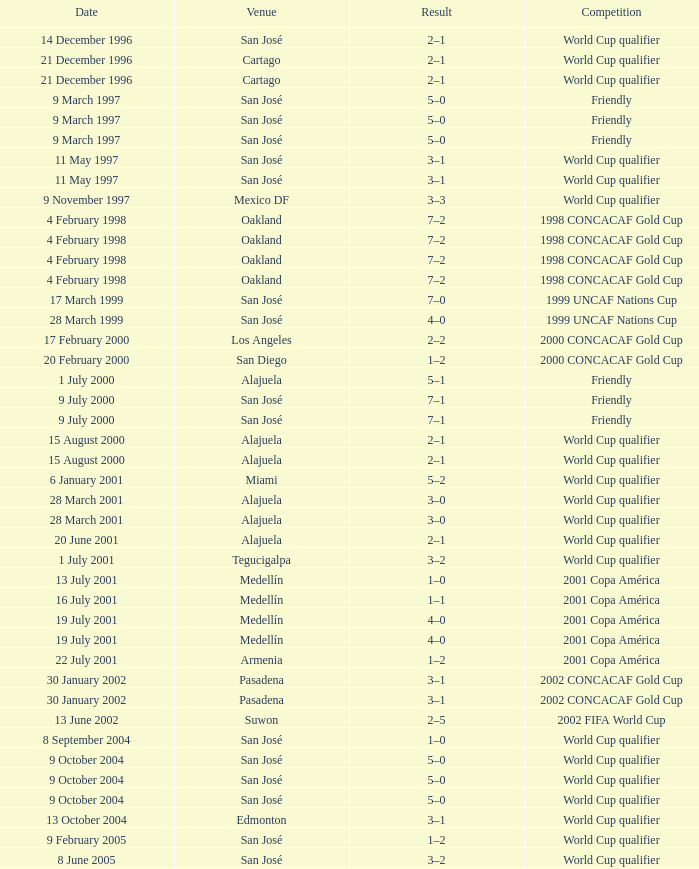What is the result in oakland? 7–2, 7–2, 7–2, 7–2. 